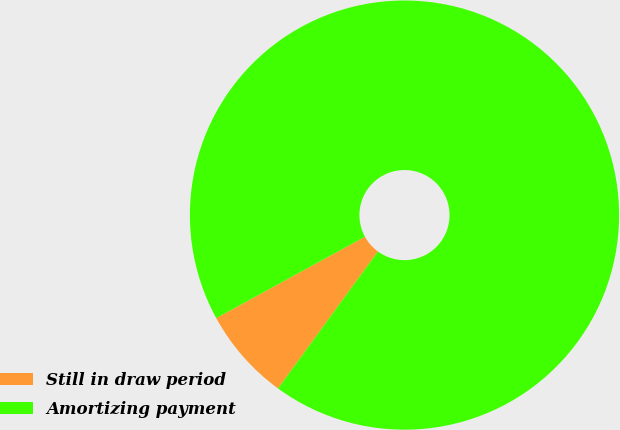<chart> <loc_0><loc_0><loc_500><loc_500><pie_chart><fcel>Still in draw period<fcel>Amortizing payment<nl><fcel>7.0%<fcel>93.0%<nl></chart> 